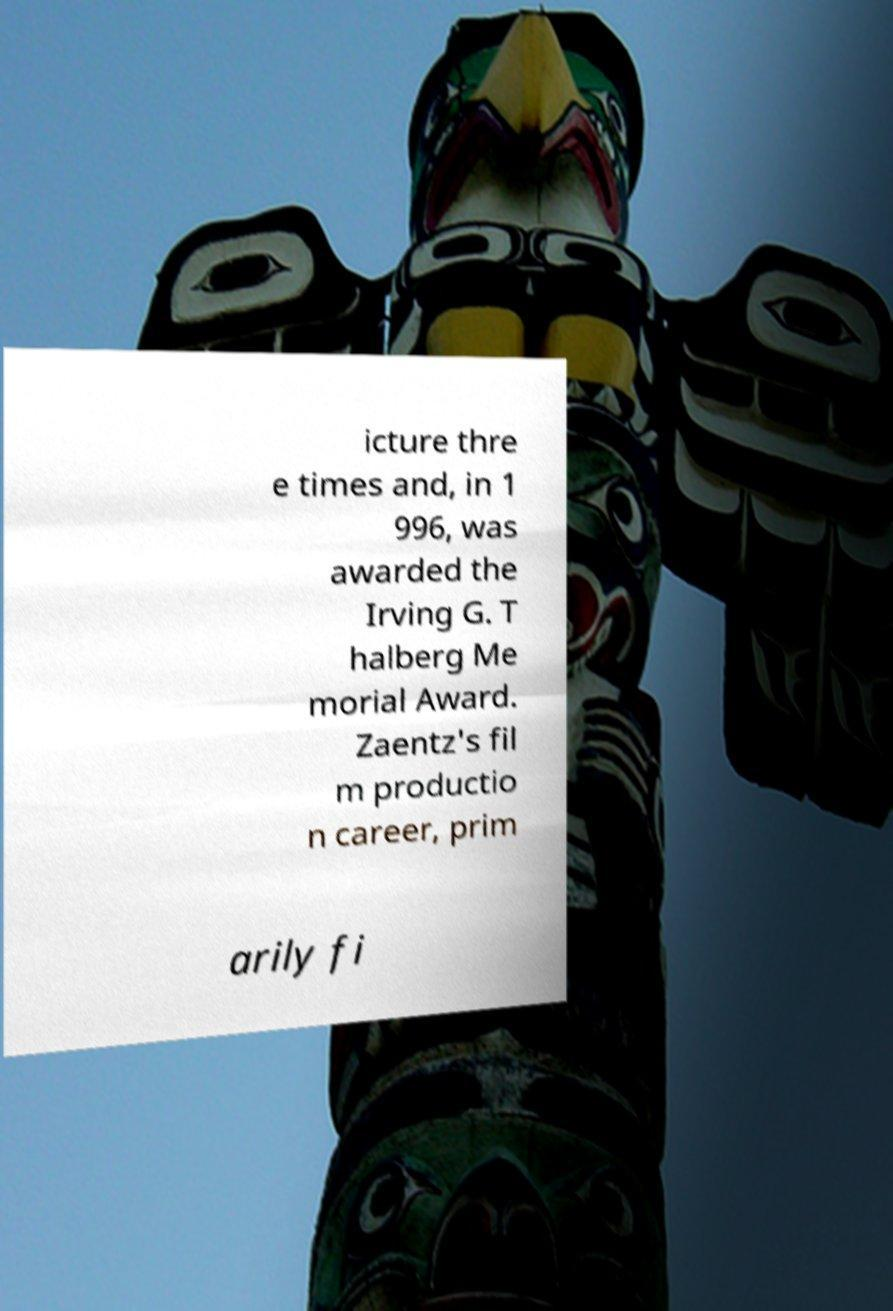Can you read and provide the text displayed in the image?This photo seems to have some interesting text. Can you extract and type it out for me? icture thre e times and, in 1 996, was awarded the Irving G. T halberg Me morial Award. Zaentz's fil m productio n career, prim arily fi 